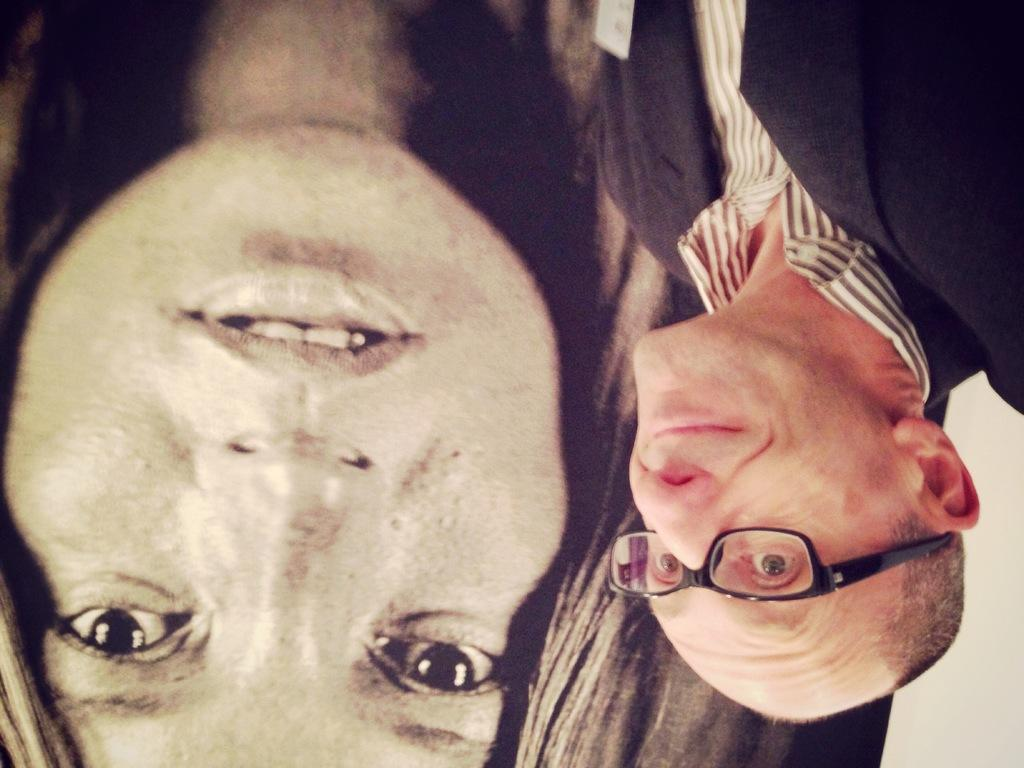How many people are in the image? There are two people in the image, a woman and a man. What is the man wearing in the image? The man is wearing a shirt, a blazer, and spectacles. What type of verse is the man reciting in the image? There is no indication in the image that the man is reciting any verse, so it cannot be determined from the picture. 